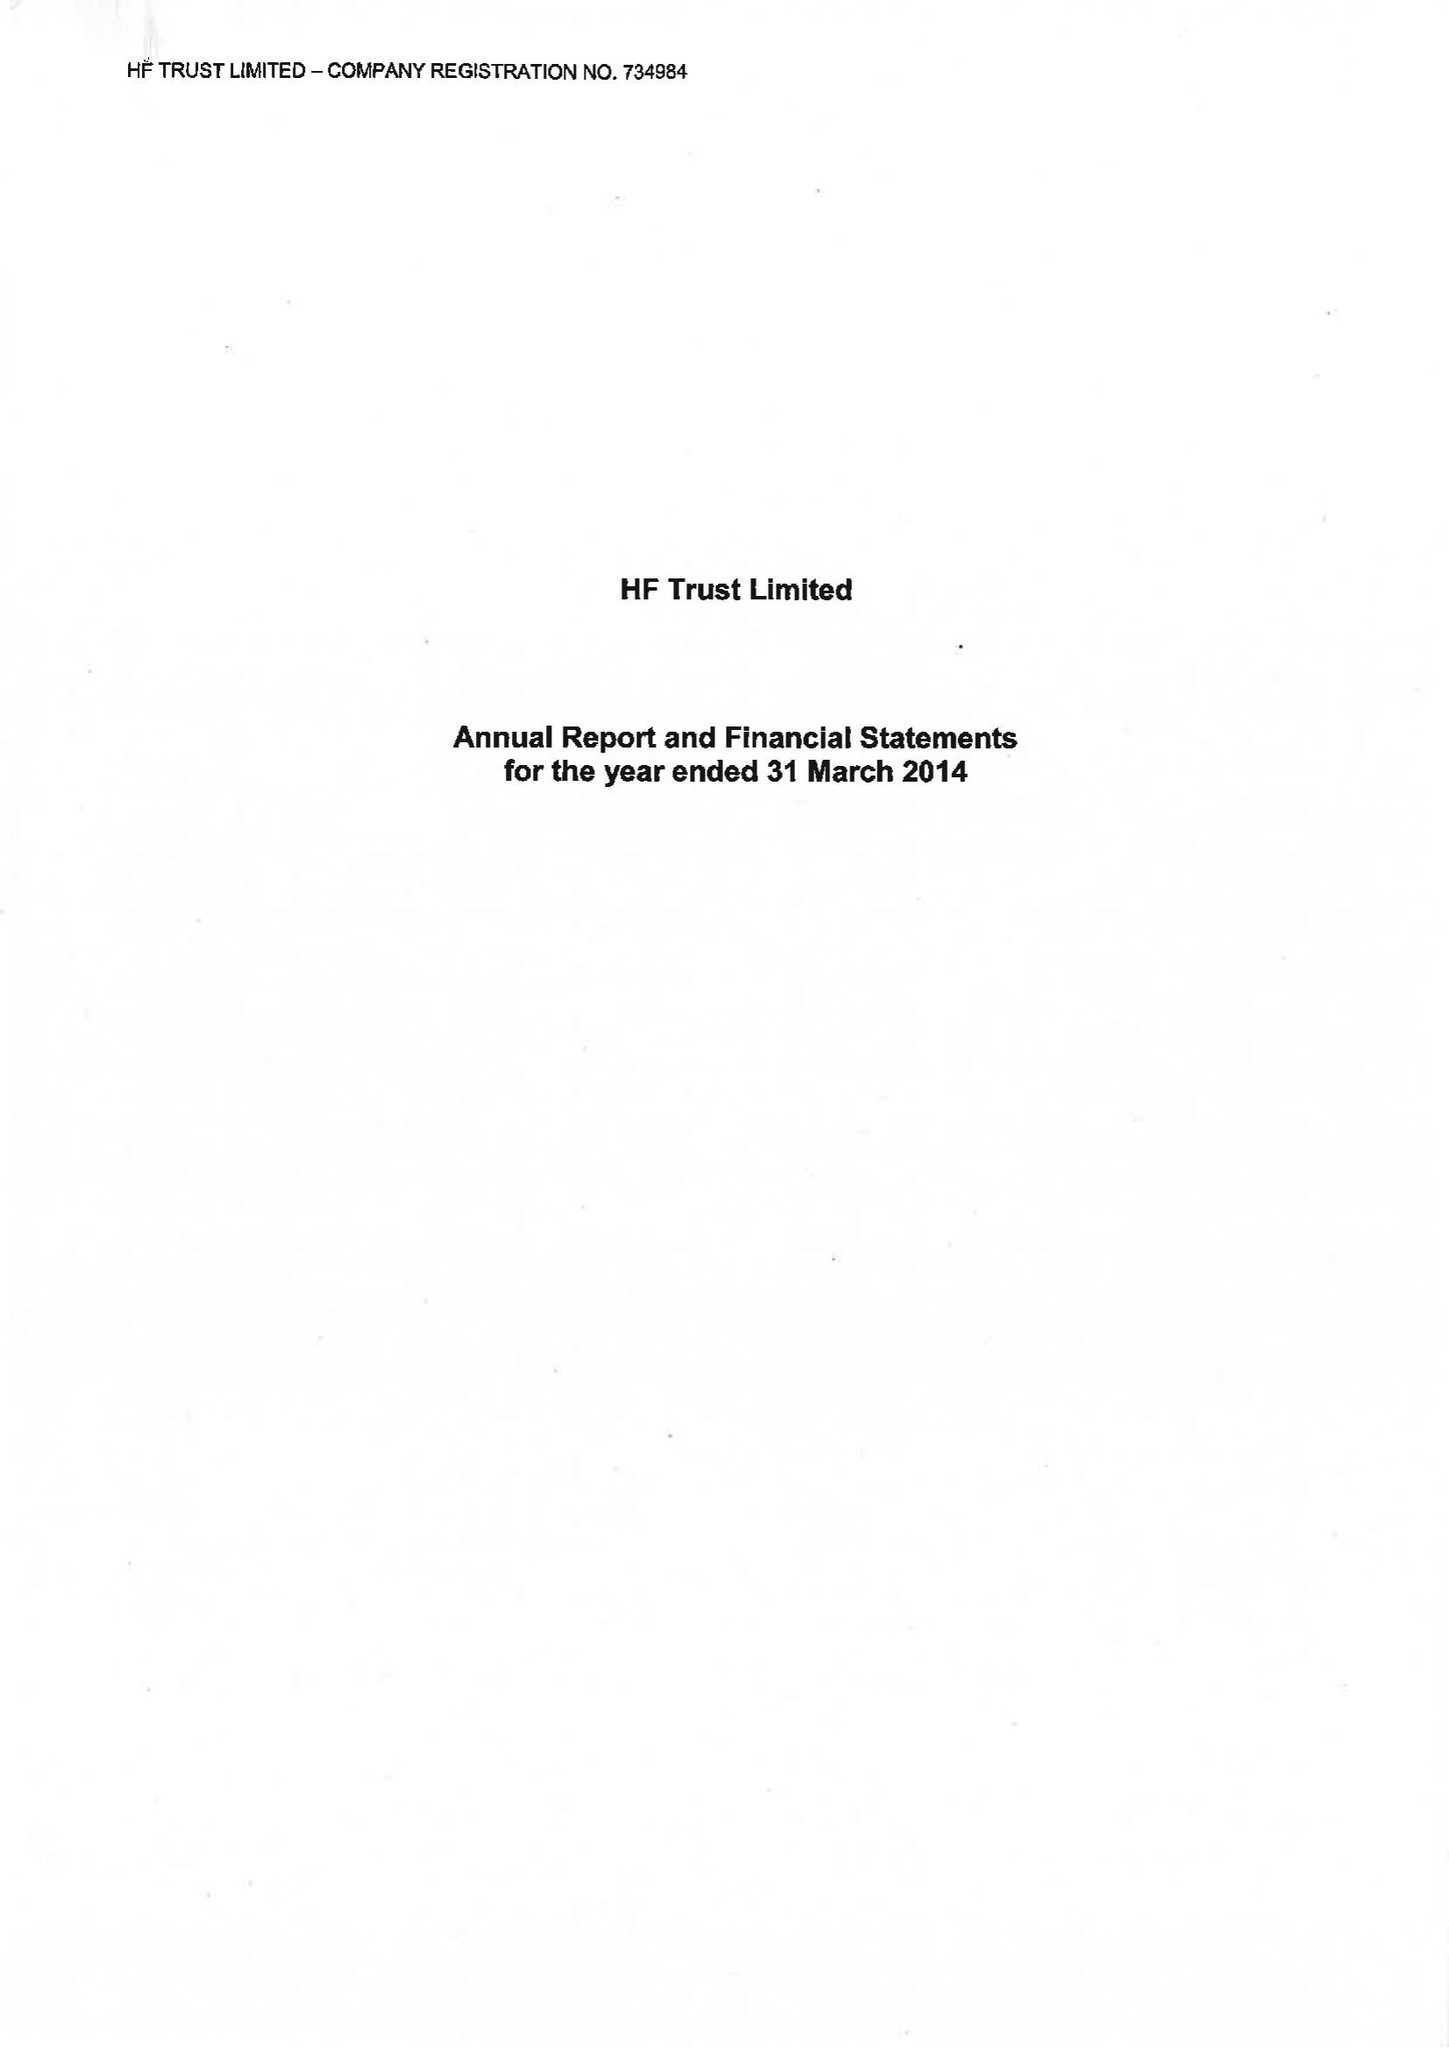What is the value for the charity_number?
Answer the question using a single word or phrase. 313069 